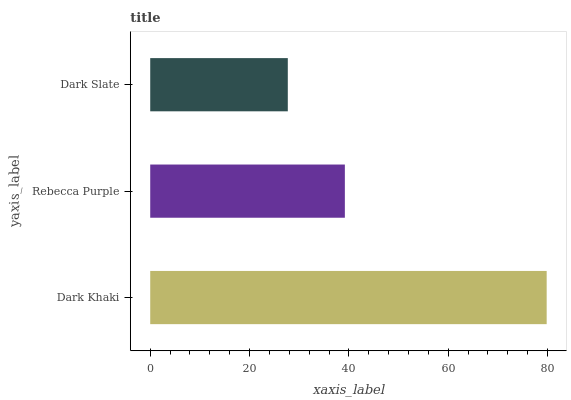Is Dark Slate the minimum?
Answer yes or no. Yes. Is Dark Khaki the maximum?
Answer yes or no. Yes. Is Rebecca Purple the minimum?
Answer yes or no. No. Is Rebecca Purple the maximum?
Answer yes or no. No. Is Dark Khaki greater than Rebecca Purple?
Answer yes or no. Yes. Is Rebecca Purple less than Dark Khaki?
Answer yes or no. Yes. Is Rebecca Purple greater than Dark Khaki?
Answer yes or no. No. Is Dark Khaki less than Rebecca Purple?
Answer yes or no. No. Is Rebecca Purple the high median?
Answer yes or no. Yes. Is Rebecca Purple the low median?
Answer yes or no. Yes. Is Dark Slate the high median?
Answer yes or no. No. Is Dark Slate the low median?
Answer yes or no. No. 